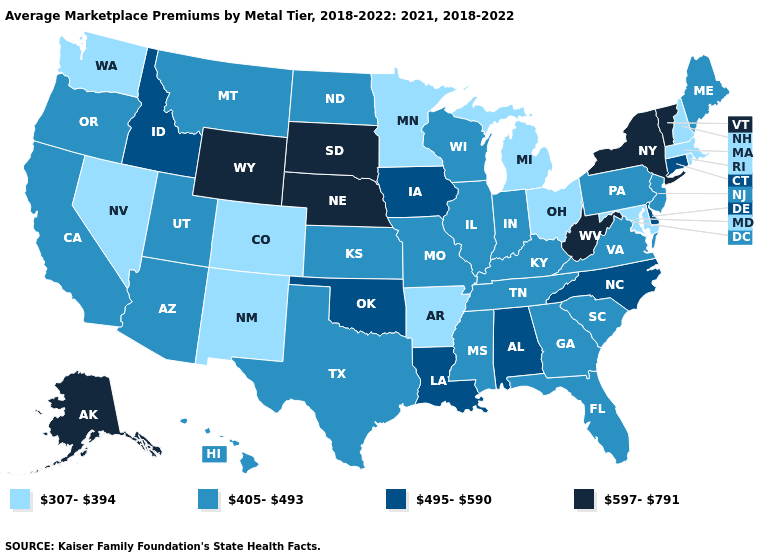What is the value of Georgia?
Short answer required. 405-493. What is the value of Utah?
Be succinct. 405-493. Which states have the lowest value in the South?
Answer briefly. Arkansas, Maryland. What is the lowest value in the USA?
Answer briefly. 307-394. Name the states that have a value in the range 597-791?
Answer briefly. Alaska, Nebraska, New York, South Dakota, Vermont, West Virginia, Wyoming. What is the value of Michigan?
Be succinct. 307-394. Does Oklahoma have a higher value than Connecticut?
Keep it brief. No. Does South Carolina have the same value as Wisconsin?
Quick response, please. Yes. Name the states that have a value in the range 495-590?
Give a very brief answer. Alabama, Connecticut, Delaware, Idaho, Iowa, Louisiana, North Carolina, Oklahoma. Which states have the lowest value in the USA?
Quick response, please. Arkansas, Colorado, Maryland, Massachusetts, Michigan, Minnesota, Nevada, New Hampshire, New Mexico, Ohio, Rhode Island, Washington. What is the value of Missouri?
Write a very short answer. 405-493. Which states have the lowest value in the West?
Give a very brief answer. Colorado, Nevada, New Mexico, Washington. Which states have the lowest value in the USA?
Write a very short answer. Arkansas, Colorado, Maryland, Massachusetts, Michigan, Minnesota, Nevada, New Hampshire, New Mexico, Ohio, Rhode Island, Washington. What is the value of New Mexico?
Be succinct. 307-394. Which states hav the highest value in the Northeast?
Keep it brief. New York, Vermont. 